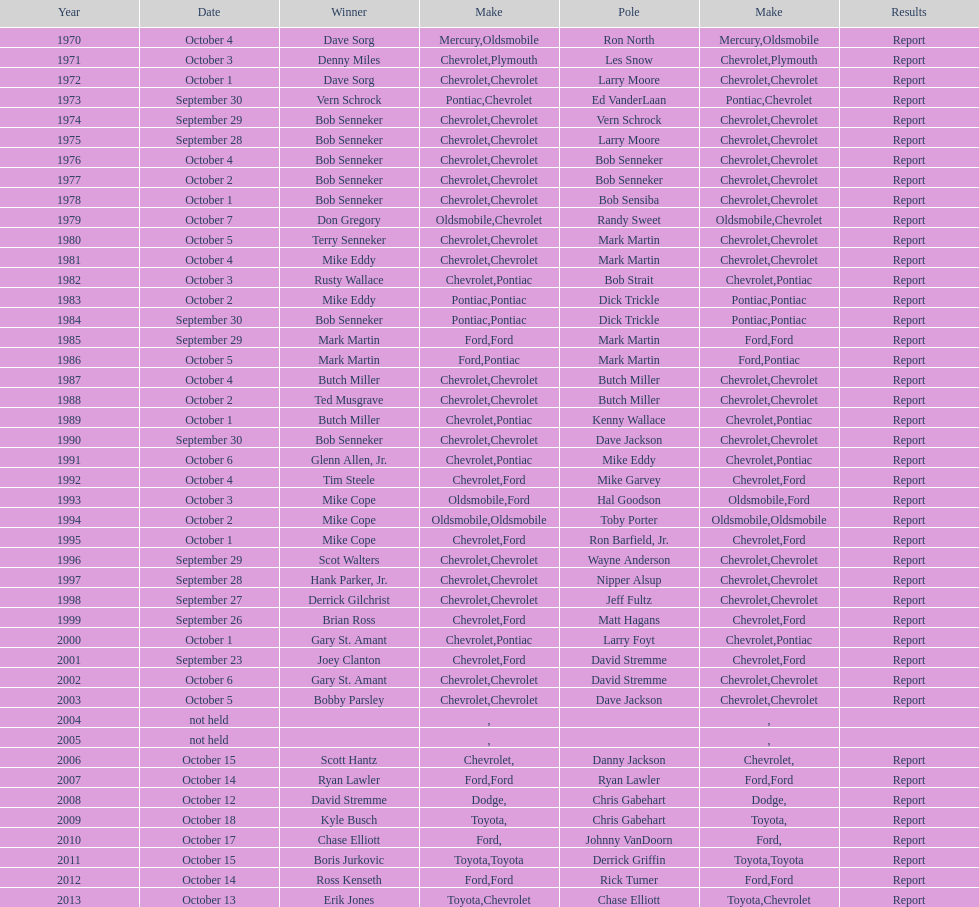Which make of car was used the least by those that won races? Toyota. 